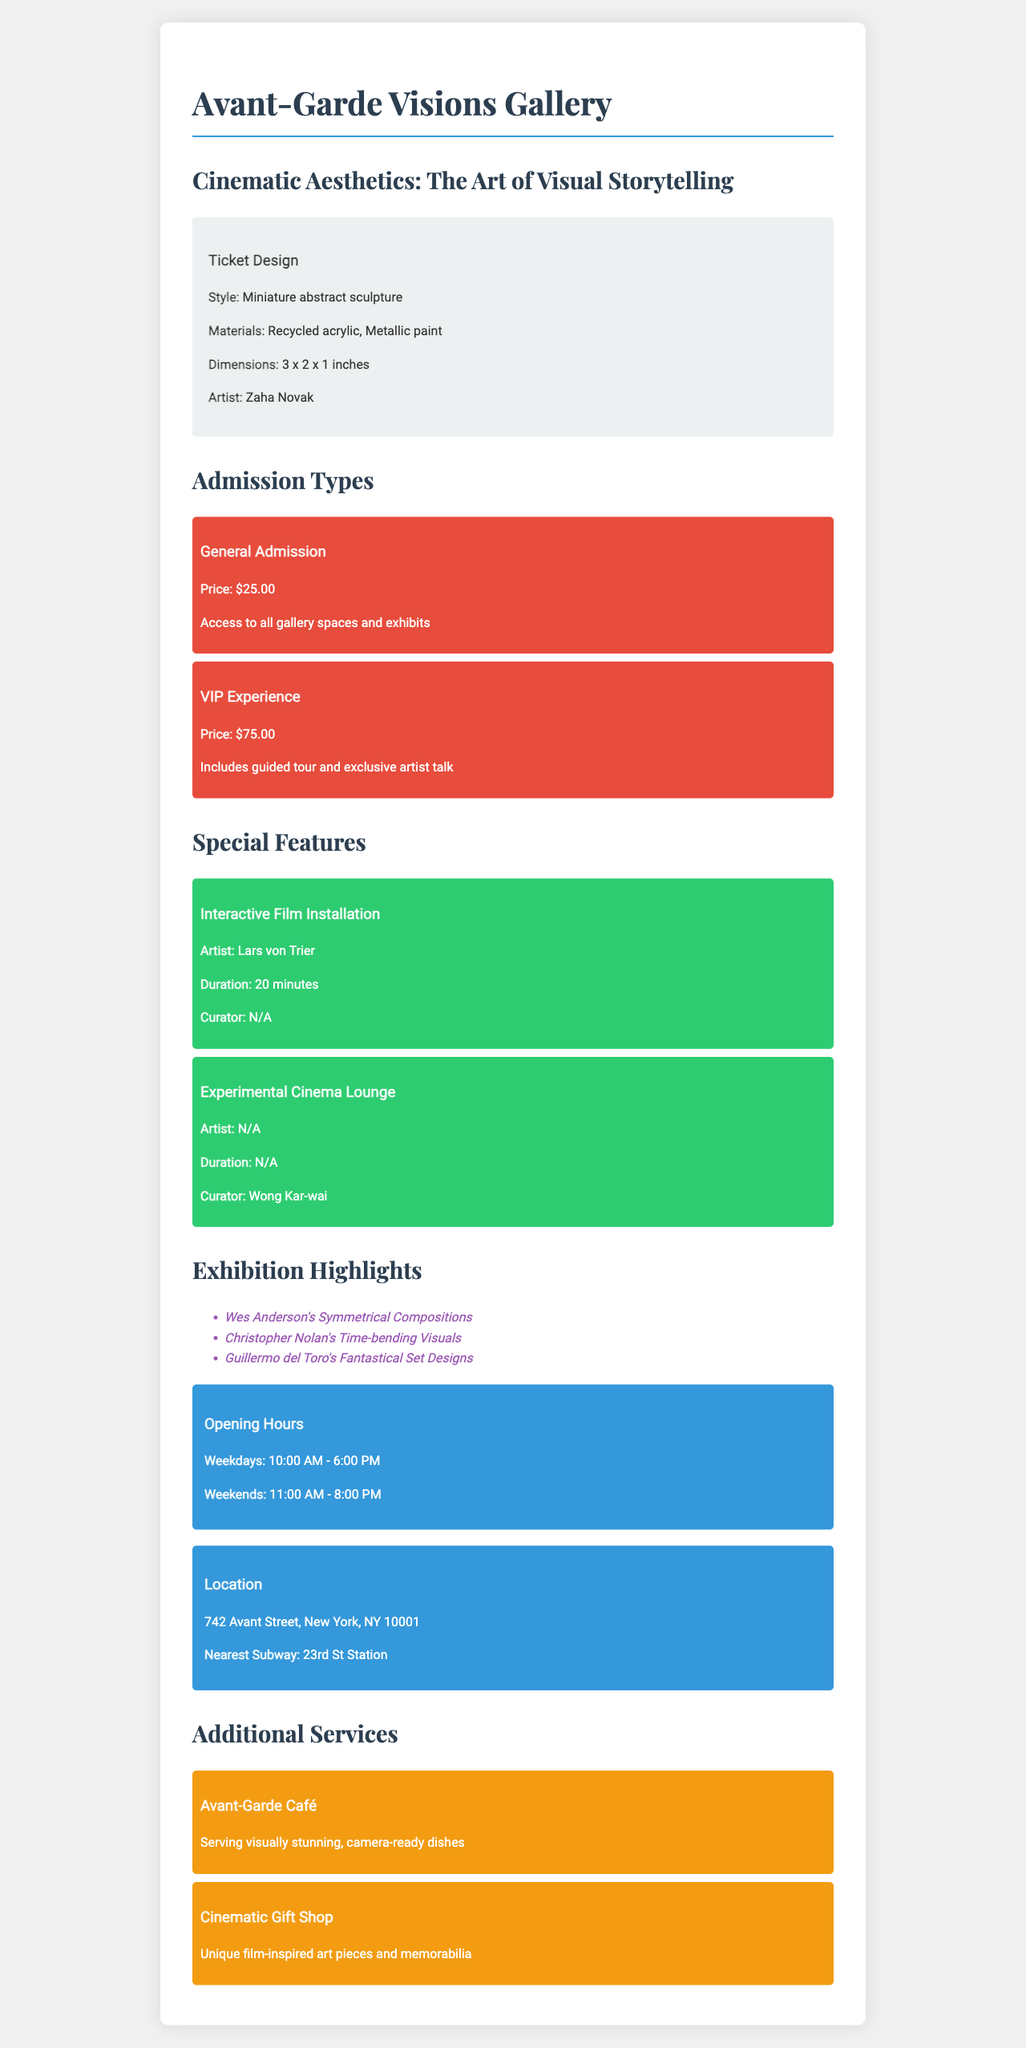What is the gallery name? The gallery name is listed prominently at the top of the document.
Answer: Avant-Garde Visions Gallery What is the price of the VIP Experience ticket? The price of the VIP Experience ticket is mentioned in the admission types section.
Answer: $75.00 Who is the artist of the ticket design? The ticket design section specifies who created the design.
Answer: Zaha Novak What is the duration of the Interactive Film Installation? The duration of this special feature is indicated in the special features section.
Answer: 20 minutes What types of materials were used for the ticket design? The materials used in the ticket design are specified in the document.
Answer: Recycled acrylic, Metallic paint How many exhibition highlights are listed? The number of highlights can be counted in the exhibition highlights section.
Answer: Three What are the opening hours on weekends? The specific opening hours for weekends are provided in the opening hours section.
Answer: 11:00 AM - 8:00 PM What additional service is provided by the Avant-Garde Café? The details about this service are described in the additional services section.
Answer: Serving visually stunning, camera-ready dishes What is the nearest subway station? The nearest subway station to the gallery is mentioned in the location section.
Answer: 23rd St Station 